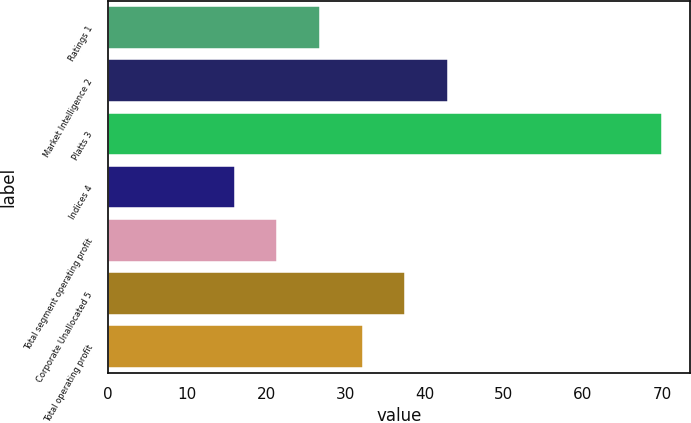<chart> <loc_0><loc_0><loc_500><loc_500><bar_chart><fcel>Ratings 1<fcel>Market Intelligence 2<fcel>Platts 3<fcel>Indices 4<fcel>Total segment operating profit<fcel>Corporate Unallocated 5<fcel>Total operating profit<nl><fcel>26.8<fcel>43<fcel>70<fcel>16<fcel>21.4<fcel>37.6<fcel>32.2<nl></chart> 